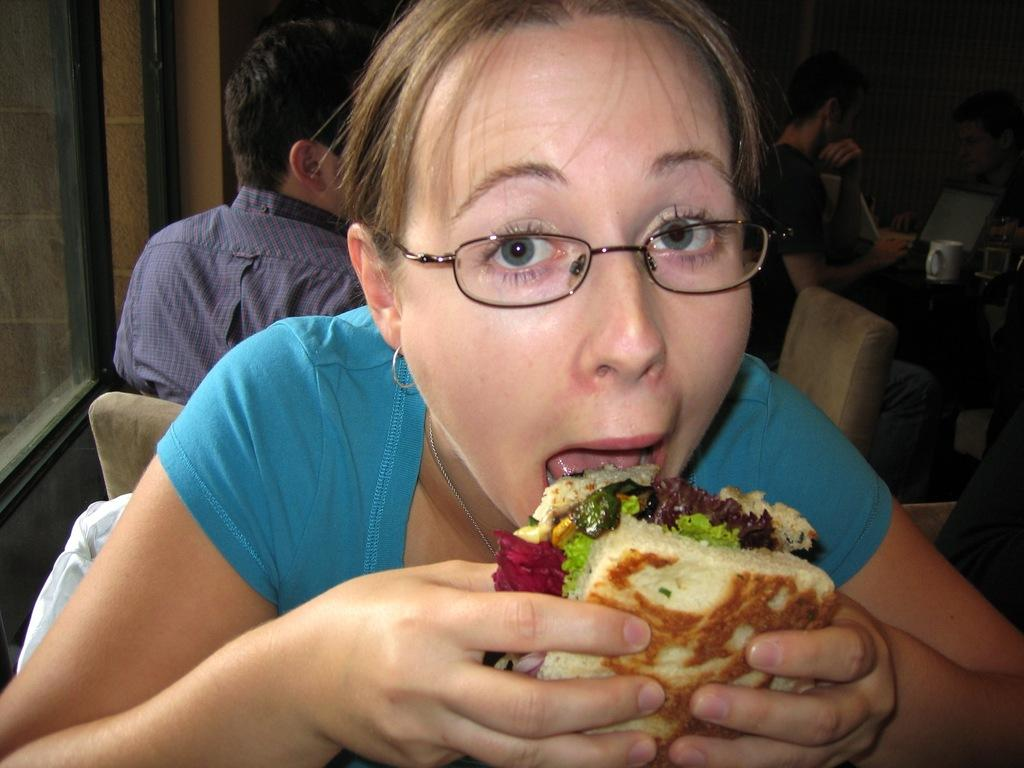What is the main subject of the image? There is a person in the image. Can you describe the person's attire? The person is wearing clothes. What is the person holding in the image? The person is holding a sandwich. Are there any other people in the image? Yes, there is another person in the top left of the image. What is the second person doing in the image? The second person is sitting on a chair. Can you see a kitty playing with a rabbit on the sidewalk in the image? No, there is no kitty, rabbit, or sidewalk present in the image. 